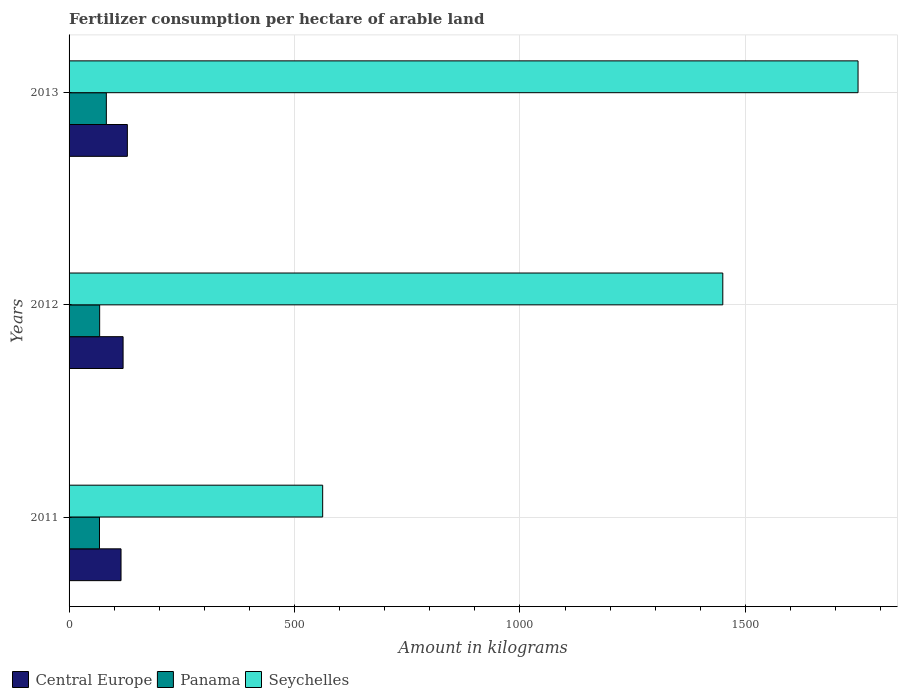How many different coloured bars are there?
Give a very brief answer. 3. Are the number of bars on each tick of the Y-axis equal?
Your answer should be very brief. Yes. How many bars are there on the 2nd tick from the top?
Provide a succinct answer. 3. How many bars are there on the 3rd tick from the bottom?
Give a very brief answer. 3. In how many cases, is the number of bars for a given year not equal to the number of legend labels?
Your answer should be very brief. 0. What is the amount of fertilizer consumption in Central Europe in 2011?
Your answer should be compact. 115.24. Across all years, what is the maximum amount of fertilizer consumption in Central Europe?
Give a very brief answer. 129.3. Across all years, what is the minimum amount of fertilizer consumption in Central Europe?
Ensure brevity in your answer.  115.24. What is the total amount of fertilizer consumption in Seychelles in the graph?
Your answer should be compact. 3762.5. What is the difference between the amount of fertilizer consumption in Central Europe in 2011 and that in 2013?
Your answer should be compact. -14.05. What is the difference between the amount of fertilizer consumption in Panama in 2013 and the amount of fertilizer consumption in Central Europe in 2012?
Your answer should be compact. -37.14. What is the average amount of fertilizer consumption in Seychelles per year?
Offer a terse response. 1254.17. In the year 2011, what is the difference between the amount of fertilizer consumption in Panama and amount of fertilizer consumption in Seychelles?
Provide a succinct answer. -495.04. In how many years, is the amount of fertilizer consumption in Panama greater than 1700 kg?
Your response must be concise. 0. What is the ratio of the amount of fertilizer consumption in Panama in 2011 to that in 2012?
Provide a short and direct response. 0.99. Is the amount of fertilizer consumption in Seychelles in 2011 less than that in 2013?
Provide a short and direct response. Yes. What is the difference between the highest and the second highest amount of fertilizer consumption in Seychelles?
Give a very brief answer. 300. What is the difference between the highest and the lowest amount of fertilizer consumption in Seychelles?
Ensure brevity in your answer.  1187.5. What does the 3rd bar from the top in 2013 represents?
Your answer should be very brief. Central Europe. What does the 3rd bar from the bottom in 2011 represents?
Your answer should be compact. Seychelles. Is it the case that in every year, the sum of the amount of fertilizer consumption in Panama and amount of fertilizer consumption in Central Europe is greater than the amount of fertilizer consumption in Seychelles?
Your answer should be very brief. No. How many bars are there?
Provide a short and direct response. 9. Does the graph contain any zero values?
Provide a short and direct response. No. Where does the legend appear in the graph?
Offer a very short reply. Bottom left. How many legend labels are there?
Your answer should be compact. 3. How are the legend labels stacked?
Your response must be concise. Horizontal. What is the title of the graph?
Your answer should be compact. Fertilizer consumption per hectare of arable land. What is the label or title of the X-axis?
Make the answer very short. Amount in kilograms. What is the Amount in kilograms in Central Europe in 2011?
Your answer should be very brief. 115.24. What is the Amount in kilograms in Panama in 2011?
Your answer should be compact. 67.46. What is the Amount in kilograms of Seychelles in 2011?
Your answer should be compact. 562.5. What is the Amount in kilograms in Central Europe in 2012?
Offer a terse response. 119.82. What is the Amount in kilograms in Panama in 2012?
Ensure brevity in your answer.  67.85. What is the Amount in kilograms in Seychelles in 2012?
Provide a succinct answer. 1450. What is the Amount in kilograms of Central Europe in 2013?
Your response must be concise. 129.3. What is the Amount in kilograms in Panama in 2013?
Your answer should be very brief. 82.67. What is the Amount in kilograms of Seychelles in 2013?
Give a very brief answer. 1750. Across all years, what is the maximum Amount in kilograms of Central Europe?
Your answer should be compact. 129.3. Across all years, what is the maximum Amount in kilograms in Panama?
Offer a terse response. 82.67. Across all years, what is the maximum Amount in kilograms of Seychelles?
Provide a succinct answer. 1750. Across all years, what is the minimum Amount in kilograms of Central Europe?
Offer a terse response. 115.24. Across all years, what is the minimum Amount in kilograms of Panama?
Provide a succinct answer. 67.46. Across all years, what is the minimum Amount in kilograms of Seychelles?
Keep it short and to the point. 562.5. What is the total Amount in kilograms of Central Europe in the graph?
Make the answer very short. 364.36. What is the total Amount in kilograms in Panama in the graph?
Your answer should be compact. 217.99. What is the total Amount in kilograms in Seychelles in the graph?
Keep it short and to the point. 3762.5. What is the difference between the Amount in kilograms in Central Europe in 2011 and that in 2012?
Give a very brief answer. -4.57. What is the difference between the Amount in kilograms of Panama in 2011 and that in 2012?
Your answer should be very brief. -0.39. What is the difference between the Amount in kilograms in Seychelles in 2011 and that in 2012?
Your answer should be very brief. -887.5. What is the difference between the Amount in kilograms of Central Europe in 2011 and that in 2013?
Provide a short and direct response. -14.05. What is the difference between the Amount in kilograms in Panama in 2011 and that in 2013?
Offer a very short reply. -15.21. What is the difference between the Amount in kilograms in Seychelles in 2011 and that in 2013?
Offer a terse response. -1187.5. What is the difference between the Amount in kilograms in Central Europe in 2012 and that in 2013?
Give a very brief answer. -9.48. What is the difference between the Amount in kilograms of Panama in 2012 and that in 2013?
Provide a succinct answer. -14.82. What is the difference between the Amount in kilograms in Seychelles in 2012 and that in 2013?
Your answer should be compact. -300. What is the difference between the Amount in kilograms of Central Europe in 2011 and the Amount in kilograms of Panama in 2012?
Keep it short and to the point. 47.39. What is the difference between the Amount in kilograms of Central Europe in 2011 and the Amount in kilograms of Seychelles in 2012?
Provide a succinct answer. -1334.76. What is the difference between the Amount in kilograms of Panama in 2011 and the Amount in kilograms of Seychelles in 2012?
Offer a terse response. -1382.54. What is the difference between the Amount in kilograms in Central Europe in 2011 and the Amount in kilograms in Panama in 2013?
Keep it short and to the point. 32.57. What is the difference between the Amount in kilograms in Central Europe in 2011 and the Amount in kilograms in Seychelles in 2013?
Give a very brief answer. -1634.76. What is the difference between the Amount in kilograms of Panama in 2011 and the Amount in kilograms of Seychelles in 2013?
Provide a short and direct response. -1682.54. What is the difference between the Amount in kilograms in Central Europe in 2012 and the Amount in kilograms in Panama in 2013?
Ensure brevity in your answer.  37.14. What is the difference between the Amount in kilograms of Central Europe in 2012 and the Amount in kilograms of Seychelles in 2013?
Provide a short and direct response. -1630.18. What is the difference between the Amount in kilograms of Panama in 2012 and the Amount in kilograms of Seychelles in 2013?
Offer a very short reply. -1682.15. What is the average Amount in kilograms in Central Europe per year?
Make the answer very short. 121.45. What is the average Amount in kilograms of Panama per year?
Provide a succinct answer. 72.66. What is the average Amount in kilograms of Seychelles per year?
Give a very brief answer. 1254.17. In the year 2011, what is the difference between the Amount in kilograms in Central Europe and Amount in kilograms in Panama?
Your answer should be compact. 47.78. In the year 2011, what is the difference between the Amount in kilograms in Central Europe and Amount in kilograms in Seychelles?
Ensure brevity in your answer.  -447.26. In the year 2011, what is the difference between the Amount in kilograms of Panama and Amount in kilograms of Seychelles?
Offer a terse response. -495.04. In the year 2012, what is the difference between the Amount in kilograms of Central Europe and Amount in kilograms of Panama?
Your response must be concise. 51.97. In the year 2012, what is the difference between the Amount in kilograms of Central Europe and Amount in kilograms of Seychelles?
Give a very brief answer. -1330.18. In the year 2012, what is the difference between the Amount in kilograms of Panama and Amount in kilograms of Seychelles?
Offer a terse response. -1382.15. In the year 2013, what is the difference between the Amount in kilograms of Central Europe and Amount in kilograms of Panama?
Your answer should be very brief. 46.62. In the year 2013, what is the difference between the Amount in kilograms in Central Europe and Amount in kilograms in Seychelles?
Ensure brevity in your answer.  -1620.7. In the year 2013, what is the difference between the Amount in kilograms in Panama and Amount in kilograms in Seychelles?
Ensure brevity in your answer.  -1667.33. What is the ratio of the Amount in kilograms of Central Europe in 2011 to that in 2012?
Your answer should be very brief. 0.96. What is the ratio of the Amount in kilograms of Seychelles in 2011 to that in 2012?
Offer a very short reply. 0.39. What is the ratio of the Amount in kilograms of Central Europe in 2011 to that in 2013?
Offer a terse response. 0.89. What is the ratio of the Amount in kilograms in Panama in 2011 to that in 2013?
Your response must be concise. 0.82. What is the ratio of the Amount in kilograms of Seychelles in 2011 to that in 2013?
Offer a terse response. 0.32. What is the ratio of the Amount in kilograms of Central Europe in 2012 to that in 2013?
Ensure brevity in your answer.  0.93. What is the ratio of the Amount in kilograms in Panama in 2012 to that in 2013?
Your answer should be compact. 0.82. What is the ratio of the Amount in kilograms of Seychelles in 2012 to that in 2013?
Offer a very short reply. 0.83. What is the difference between the highest and the second highest Amount in kilograms of Central Europe?
Provide a short and direct response. 9.48. What is the difference between the highest and the second highest Amount in kilograms in Panama?
Your answer should be compact. 14.82. What is the difference between the highest and the second highest Amount in kilograms in Seychelles?
Your answer should be compact. 300. What is the difference between the highest and the lowest Amount in kilograms in Central Europe?
Your answer should be compact. 14.05. What is the difference between the highest and the lowest Amount in kilograms in Panama?
Your answer should be very brief. 15.21. What is the difference between the highest and the lowest Amount in kilograms of Seychelles?
Keep it short and to the point. 1187.5. 